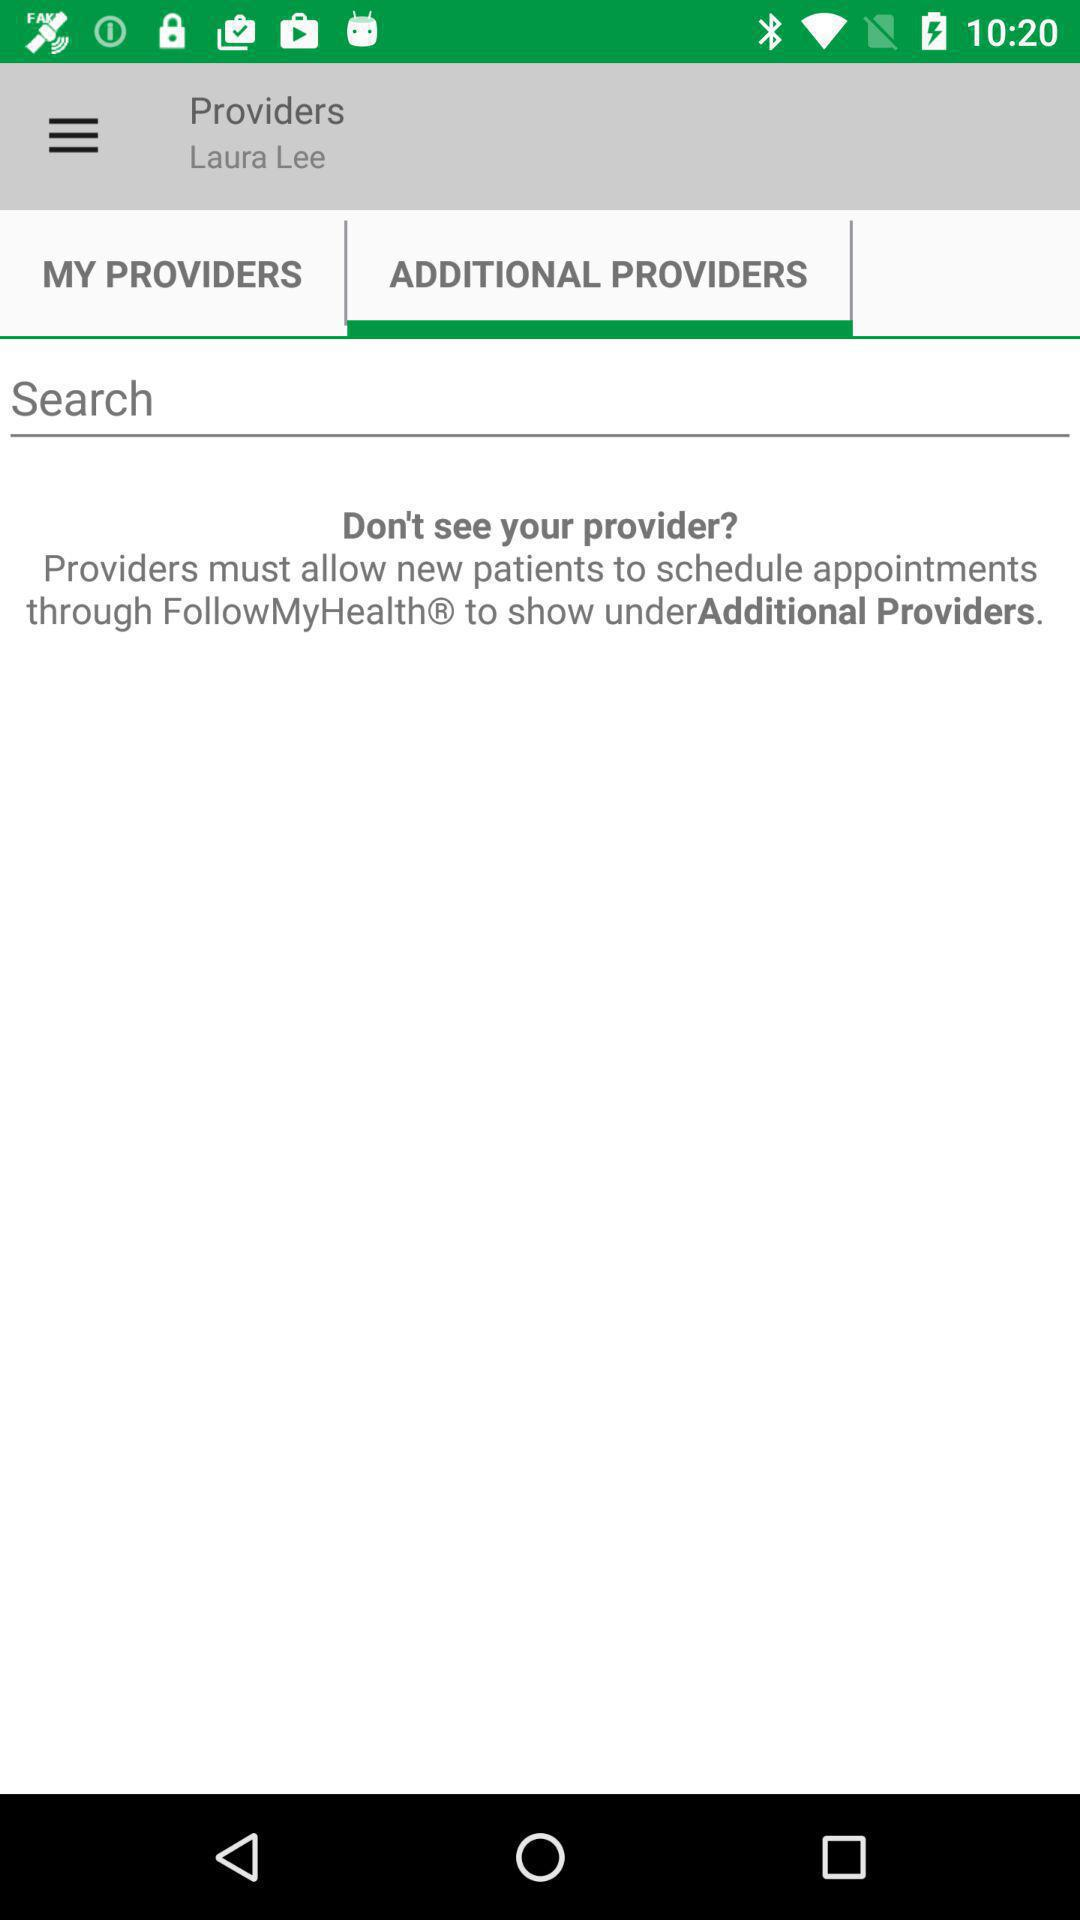What is the name of the user? The name of the user is Laura Lee. 